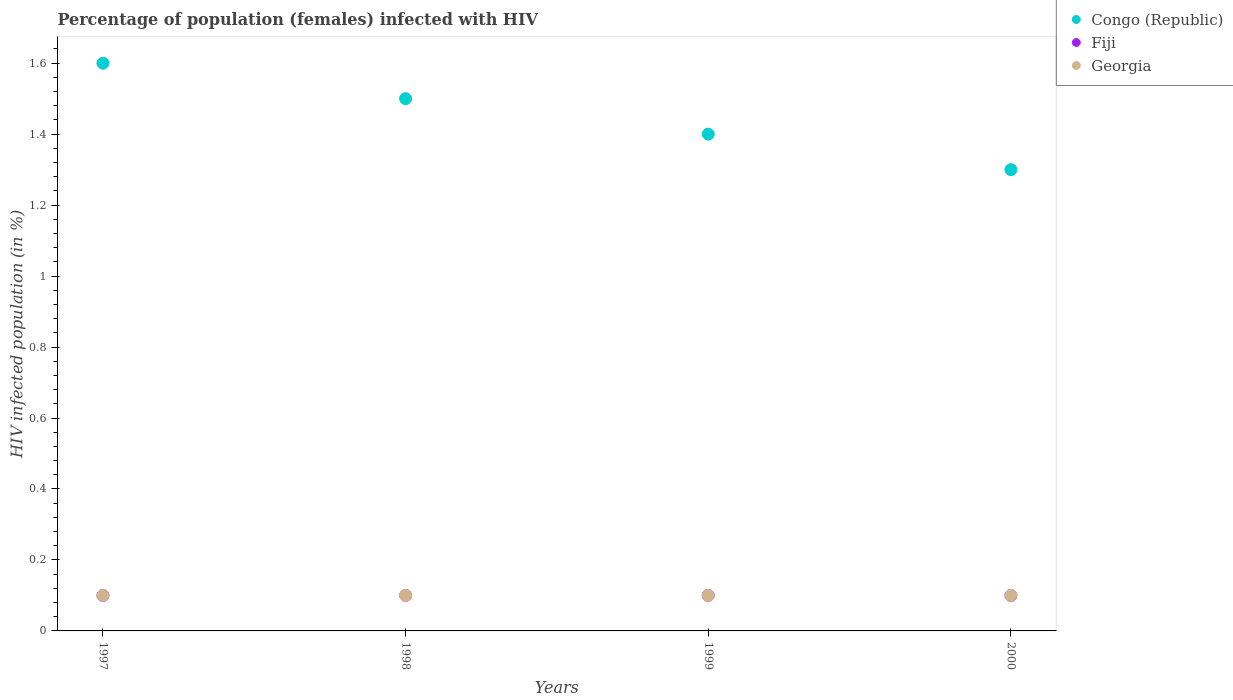How many different coloured dotlines are there?
Offer a very short reply. 3. What is the percentage of HIV infected female population in Fiji in 1997?
Your answer should be very brief. 0.1. Across all years, what is the maximum percentage of HIV infected female population in Congo (Republic)?
Your answer should be compact. 1.6. Across all years, what is the minimum percentage of HIV infected female population in Fiji?
Keep it short and to the point. 0.1. What is the total percentage of HIV infected female population in Fiji in the graph?
Offer a terse response. 0.4. What is the difference between the percentage of HIV infected female population in Fiji in 1998 and the percentage of HIV infected female population in Congo (Republic) in 1999?
Keep it short and to the point. -1.3. What is the average percentage of HIV infected female population in Fiji per year?
Ensure brevity in your answer.  0.1. In how many years, is the percentage of HIV infected female population in Congo (Republic) greater than 0.08 %?
Provide a succinct answer. 4. What is the ratio of the percentage of HIV infected female population in Fiji in 1998 to that in 2000?
Offer a very short reply. 1. Is the percentage of HIV infected female population in Congo (Republic) in 1997 less than that in 1999?
Your answer should be very brief. No. Is the difference between the percentage of HIV infected female population in Congo (Republic) in 1997 and 1998 greater than the difference between the percentage of HIV infected female population in Georgia in 1997 and 1998?
Provide a short and direct response. Yes. What is the difference between the highest and the lowest percentage of HIV infected female population in Georgia?
Your answer should be very brief. 0. Is it the case that in every year, the sum of the percentage of HIV infected female population in Georgia and percentage of HIV infected female population in Fiji  is greater than the percentage of HIV infected female population in Congo (Republic)?
Your answer should be very brief. No. Is the percentage of HIV infected female population in Congo (Republic) strictly greater than the percentage of HIV infected female population in Georgia over the years?
Make the answer very short. Yes. Is the percentage of HIV infected female population in Fiji strictly less than the percentage of HIV infected female population in Congo (Republic) over the years?
Your response must be concise. Yes. How many dotlines are there?
Provide a succinct answer. 3. How many years are there in the graph?
Give a very brief answer. 4. Are the values on the major ticks of Y-axis written in scientific E-notation?
Ensure brevity in your answer.  No. Does the graph contain any zero values?
Give a very brief answer. No. Does the graph contain grids?
Provide a short and direct response. No. Where does the legend appear in the graph?
Ensure brevity in your answer.  Top right. What is the title of the graph?
Your response must be concise. Percentage of population (females) infected with HIV. What is the label or title of the Y-axis?
Give a very brief answer. HIV infected population (in %). What is the HIV infected population (in %) in Fiji in 1997?
Give a very brief answer. 0.1. What is the HIV infected population (in %) in Congo (Republic) in 1999?
Ensure brevity in your answer.  1.4. What is the HIV infected population (in %) in Fiji in 1999?
Give a very brief answer. 0.1. What is the HIV infected population (in %) in Georgia in 1999?
Ensure brevity in your answer.  0.1. Across all years, what is the maximum HIV infected population (in %) in Congo (Republic)?
Provide a short and direct response. 1.6. Across all years, what is the maximum HIV infected population (in %) in Fiji?
Make the answer very short. 0.1. Across all years, what is the maximum HIV infected population (in %) in Georgia?
Keep it short and to the point. 0.1. What is the total HIV infected population (in %) in Congo (Republic) in the graph?
Provide a succinct answer. 5.8. What is the total HIV infected population (in %) in Fiji in the graph?
Give a very brief answer. 0.4. What is the total HIV infected population (in %) in Georgia in the graph?
Provide a succinct answer. 0.4. What is the difference between the HIV infected population (in %) in Congo (Republic) in 1997 and that in 1998?
Keep it short and to the point. 0.1. What is the difference between the HIV infected population (in %) in Fiji in 1997 and that in 1998?
Ensure brevity in your answer.  0. What is the difference between the HIV infected population (in %) of Georgia in 1997 and that in 1998?
Make the answer very short. 0. What is the difference between the HIV infected population (in %) in Congo (Republic) in 1997 and that in 2000?
Give a very brief answer. 0.3. What is the difference between the HIV infected population (in %) in Fiji in 1998 and that in 1999?
Provide a succinct answer. 0. What is the difference between the HIV infected population (in %) in Fiji in 1998 and that in 2000?
Your answer should be very brief. 0. What is the difference between the HIV infected population (in %) of Georgia in 1998 and that in 2000?
Offer a very short reply. 0. What is the difference between the HIV infected population (in %) in Congo (Republic) in 1999 and that in 2000?
Offer a terse response. 0.1. What is the difference between the HIV infected population (in %) in Fiji in 1999 and that in 2000?
Ensure brevity in your answer.  0. What is the difference between the HIV infected population (in %) of Georgia in 1999 and that in 2000?
Keep it short and to the point. 0. What is the difference between the HIV infected population (in %) in Congo (Republic) in 1997 and the HIV infected population (in %) in Georgia in 1998?
Provide a short and direct response. 1.5. What is the difference between the HIV infected population (in %) in Fiji in 1997 and the HIV infected population (in %) in Georgia in 1998?
Give a very brief answer. 0. What is the difference between the HIV infected population (in %) of Fiji in 1997 and the HIV infected population (in %) of Georgia in 1999?
Your answer should be very brief. 0. What is the difference between the HIV infected population (in %) in Congo (Republic) in 1997 and the HIV infected population (in %) in Fiji in 2000?
Your answer should be compact. 1.5. What is the difference between the HIV infected population (in %) in Fiji in 1997 and the HIV infected population (in %) in Georgia in 2000?
Make the answer very short. 0. What is the difference between the HIV infected population (in %) of Fiji in 1998 and the HIV infected population (in %) of Georgia in 1999?
Keep it short and to the point. 0. What is the difference between the HIV infected population (in %) in Congo (Republic) in 1998 and the HIV infected population (in %) in Georgia in 2000?
Your answer should be very brief. 1.4. What is the difference between the HIV infected population (in %) of Congo (Republic) in 1999 and the HIV infected population (in %) of Georgia in 2000?
Ensure brevity in your answer.  1.3. What is the average HIV infected population (in %) of Congo (Republic) per year?
Give a very brief answer. 1.45. What is the average HIV infected population (in %) in Georgia per year?
Offer a very short reply. 0.1. In the year 1997, what is the difference between the HIV infected population (in %) of Congo (Republic) and HIV infected population (in %) of Georgia?
Your answer should be compact. 1.5. In the year 1998, what is the difference between the HIV infected population (in %) in Congo (Republic) and HIV infected population (in %) in Fiji?
Your answer should be very brief. 1.4. In the year 1998, what is the difference between the HIV infected population (in %) in Congo (Republic) and HIV infected population (in %) in Georgia?
Your answer should be compact. 1.4. In the year 1998, what is the difference between the HIV infected population (in %) of Fiji and HIV infected population (in %) of Georgia?
Provide a short and direct response. 0. In the year 1999, what is the difference between the HIV infected population (in %) of Congo (Republic) and HIV infected population (in %) of Fiji?
Offer a very short reply. 1.3. In the year 1999, what is the difference between the HIV infected population (in %) in Congo (Republic) and HIV infected population (in %) in Georgia?
Provide a succinct answer. 1.3. In the year 2000, what is the difference between the HIV infected population (in %) of Congo (Republic) and HIV infected population (in %) of Georgia?
Provide a short and direct response. 1.2. What is the ratio of the HIV infected population (in %) of Congo (Republic) in 1997 to that in 1998?
Offer a terse response. 1.07. What is the ratio of the HIV infected population (in %) of Georgia in 1997 to that in 1998?
Your answer should be very brief. 1. What is the ratio of the HIV infected population (in %) of Congo (Republic) in 1997 to that in 1999?
Ensure brevity in your answer.  1.14. What is the ratio of the HIV infected population (in %) in Congo (Republic) in 1997 to that in 2000?
Offer a very short reply. 1.23. What is the ratio of the HIV infected population (in %) in Georgia in 1997 to that in 2000?
Offer a terse response. 1. What is the ratio of the HIV infected population (in %) of Congo (Republic) in 1998 to that in 1999?
Provide a short and direct response. 1.07. What is the ratio of the HIV infected population (in %) in Fiji in 1998 to that in 1999?
Your answer should be very brief. 1. What is the ratio of the HIV infected population (in %) in Congo (Republic) in 1998 to that in 2000?
Give a very brief answer. 1.15. What is the ratio of the HIV infected population (in %) in Fiji in 1998 to that in 2000?
Ensure brevity in your answer.  1. What is the ratio of the HIV infected population (in %) in Georgia in 1999 to that in 2000?
Keep it short and to the point. 1. What is the difference between the highest and the second highest HIV infected population (in %) of Fiji?
Your answer should be compact. 0. What is the difference between the highest and the second highest HIV infected population (in %) in Georgia?
Ensure brevity in your answer.  0. What is the difference between the highest and the lowest HIV infected population (in %) of Fiji?
Offer a terse response. 0. What is the difference between the highest and the lowest HIV infected population (in %) in Georgia?
Offer a very short reply. 0. 